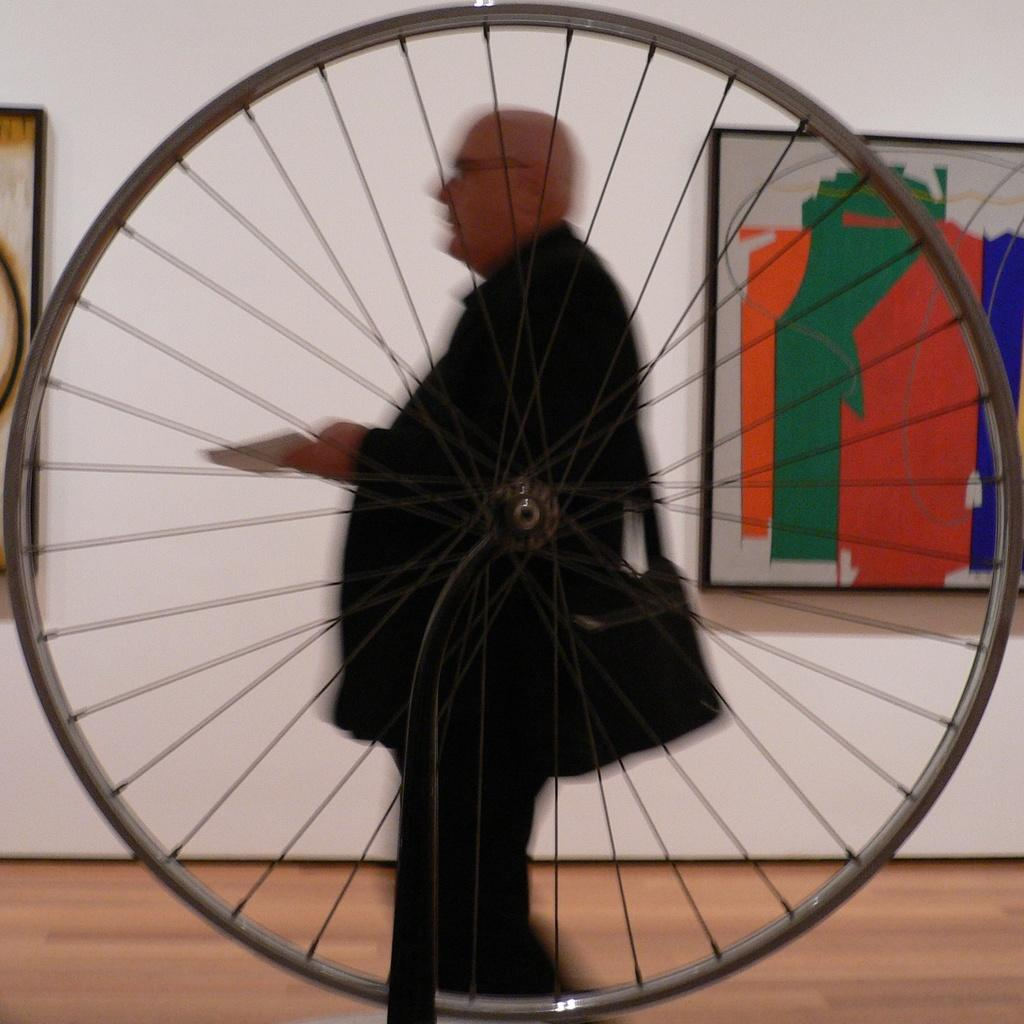What is the main object in the image? There is a cycle rim in the image. Can you describe the setting of the image? There is a person standing in the background of the image, and there is a white color wall in the background as well. What type of riddle is the person holding in the image? There is no riddle present in the image; the person is simply standing in the background. 